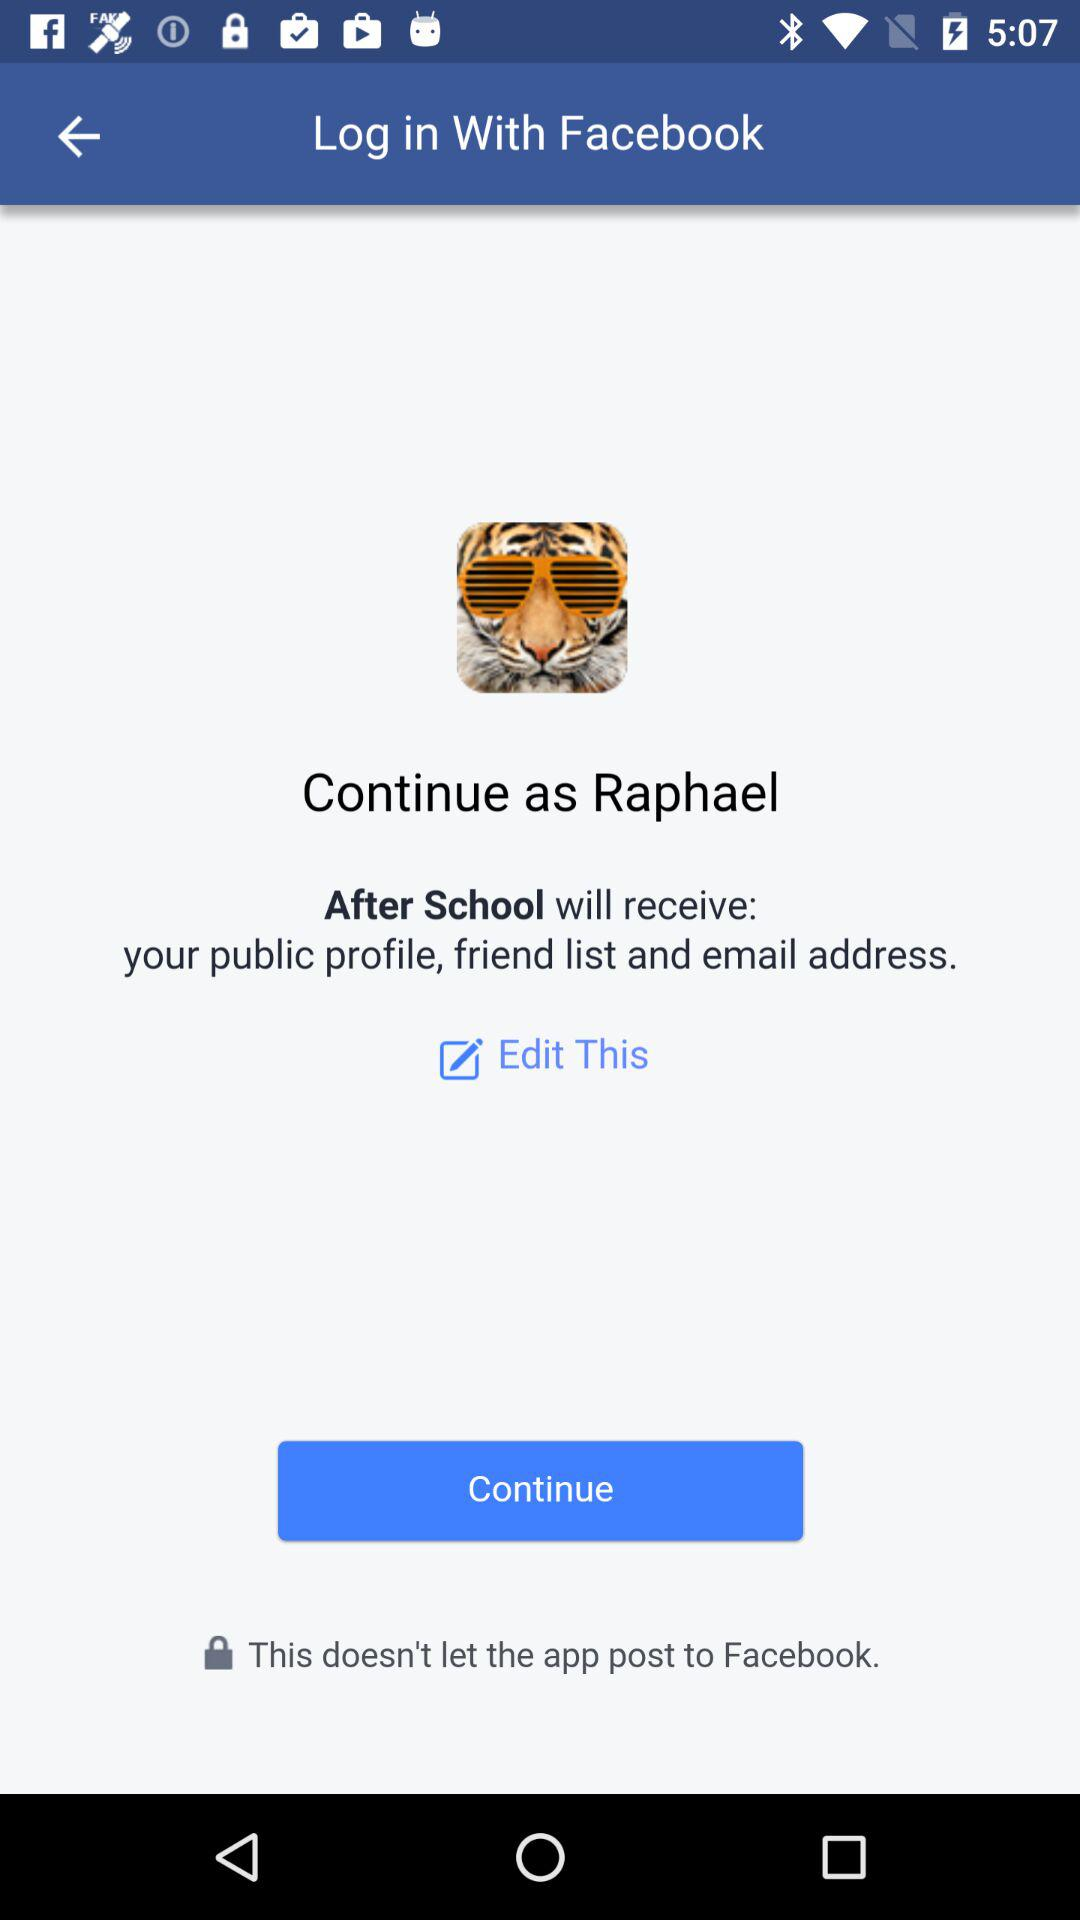What information will "After School" receive? The information "After School" will receive is your public profile, friend list, and email address. 